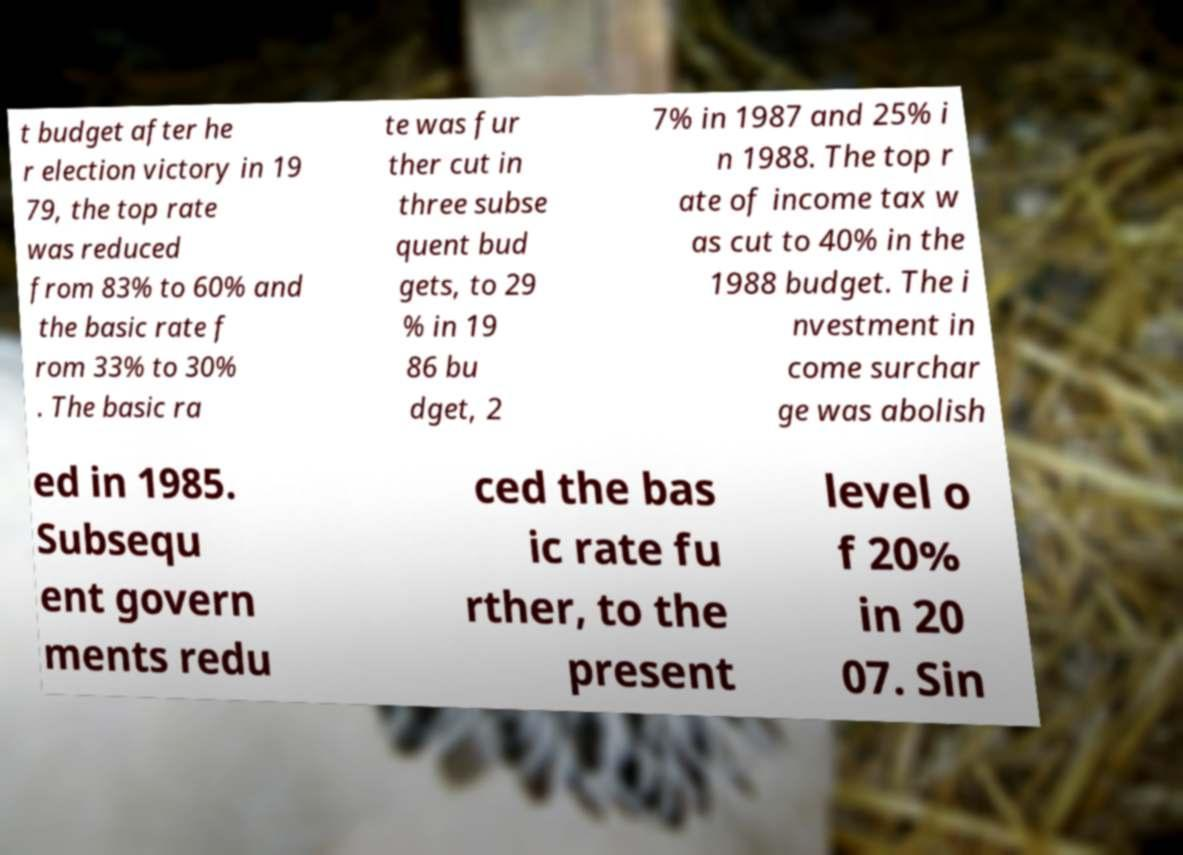Could you assist in decoding the text presented in this image and type it out clearly? t budget after he r election victory in 19 79, the top rate was reduced from 83% to 60% and the basic rate f rom 33% to 30% . The basic ra te was fur ther cut in three subse quent bud gets, to 29 % in 19 86 bu dget, 2 7% in 1987 and 25% i n 1988. The top r ate of income tax w as cut to 40% in the 1988 budget. The i nvestment in come surchar ge was abolish ed in 1985. Subsequ ent govern ments redu ced the bas ic rate fu rther, to the present level o f 20% in 20 07. Sin 